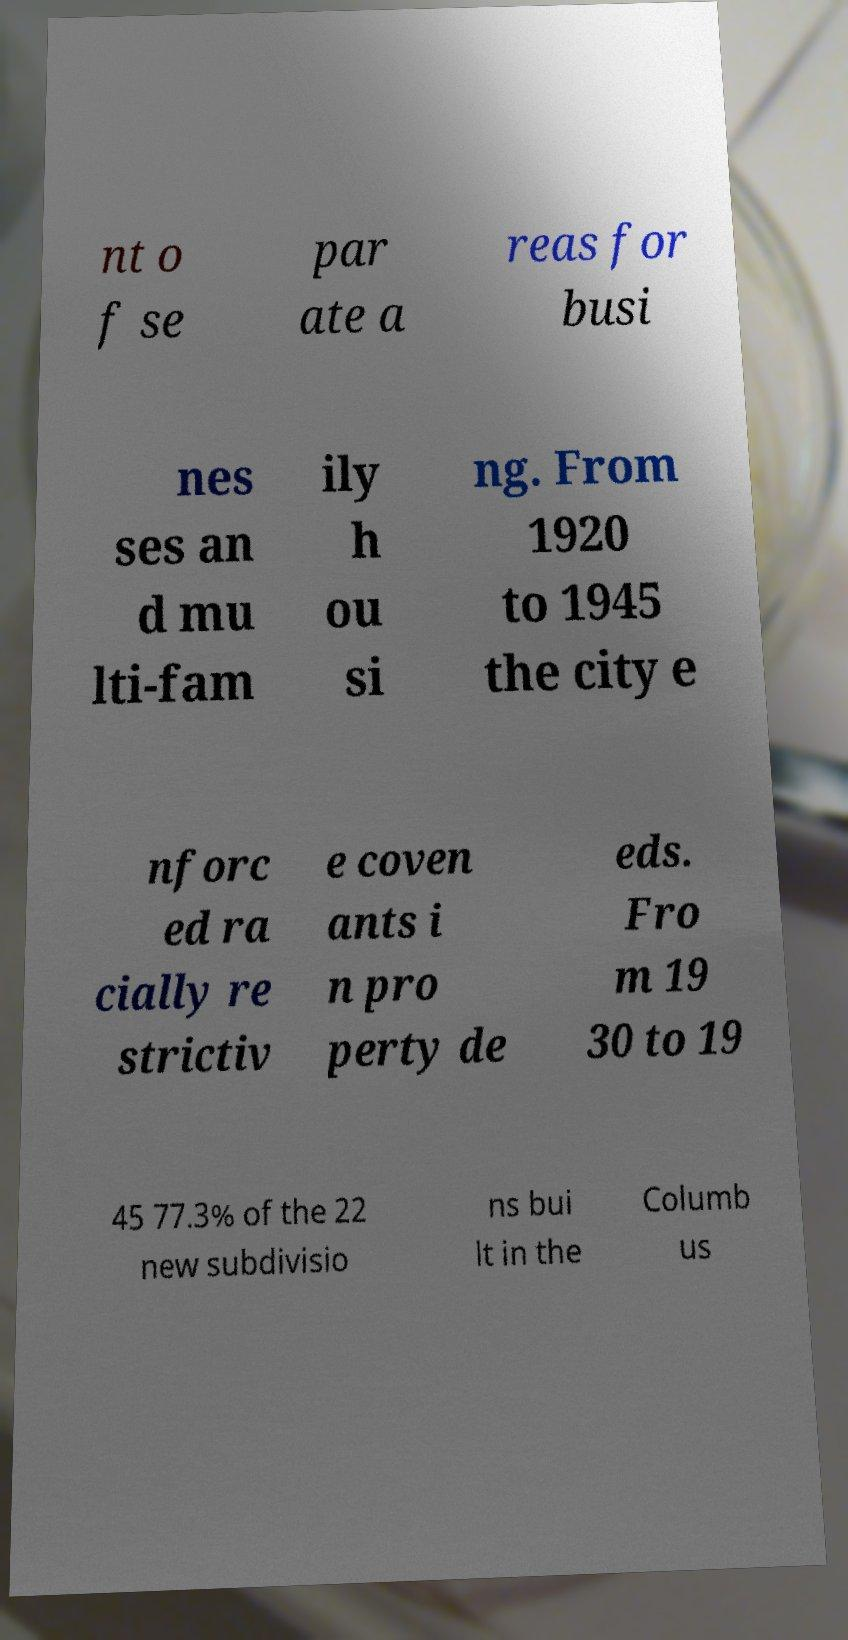Please read and relay the text visible in this image. What does it say? nt o f se par ate a reas for busi nes ses an d mu lti-fam ily h ou si ng. From 1920 to 1945 the city e nforc ed ra cially re strictiv e coven ants i n pro perty de eds. Fro m 19 30 to 19 45 77.3% of the 22 new subdivisio ns bui lt in the Columb us 